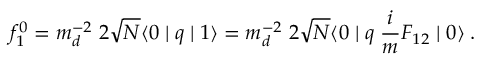<formula> <loc_0><loc_0><loc_500><loc_500>f _ { 1 } ^ { 0 } = m _ { d } ^ { - 2 } \, 2 \sqrt { N } \langle 0 | q | 1 \rangle = m _ { d } ^ { - 2 } \, 2 \sqrt { N } \langle 0 | q \, \frac { i } { m } F _ { 1 2 } | 0 \rangle \, .</formula> 